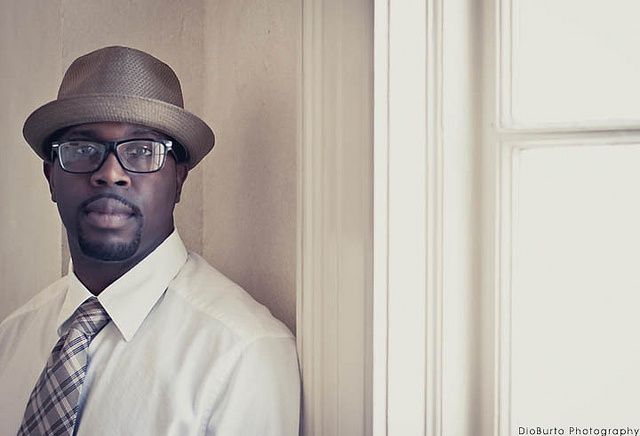Describe the objects in this image and their specific colors. I can see people in gray, lightgray, darkgray, and black tones and tie in gray, darkgray, and black tones in this image. 